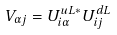Convert formula to latex. <formula><loc_0><loc_0><loc_500><loc_500>V _ { \alpha j } = U ^ { u L * } _ { i \alpha } U ^ { d L } _ { i j }</formula> 